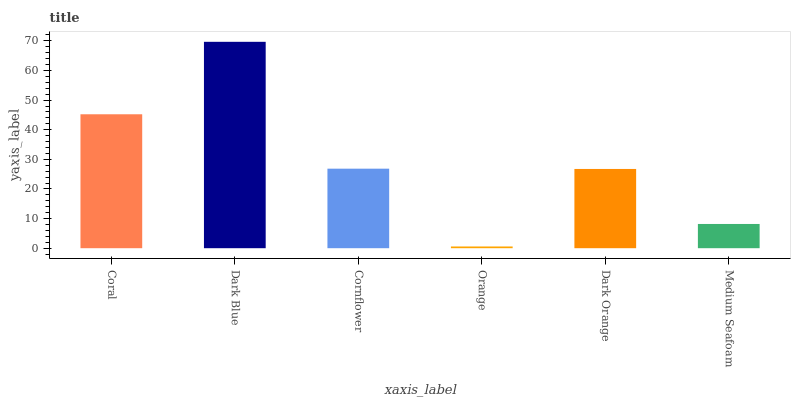Is Cornflower the minimum?
Answer yes or no. No. Is Cornflower the maximum?
Answer yes or no. No. Is Dark Blue greater than Cornflower?
Answer yes or no. Yes. Is Cornflower less than Dark Blue?
Answer yes or no. Yes. Is Cornflower greater than Dark Blue?
Answer yes or no. No. Is Dark Blue less than Cornflower?
Answer yes or no. No. Is Cornflower the high median?
Answer yes or no. Yes. Is Dark Orange the low median?
Answer yes or no. Yes. Is Coral the high median?
Answer yes or no. No. Is Medium Seafoam the low median?
Answer yes or no. No. 